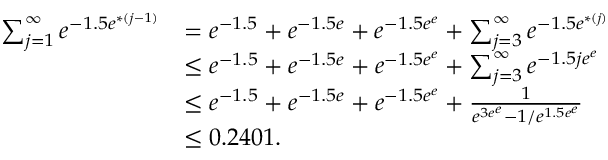Convert formula to latex. <formula><loc_0><loc_0><loc_500><loc_500>\begin{array} { r l } { \sum _ { j = 1 } ^ { \infty } e ^ { - 1 . 5 { e ^ { * ( j - 1 ) } } } } & { = { e ^ { - 1 . 5 } } + { e ^ { - 1 . 5 e } } + { e ^ { - 1 . 5 e ^ { e } } } + \sum _ { j = 3 } ^ { \infty } e ^ { - 1 . 5 { e ^ { * ( j ) } } } } \\ & { \leq { e ^ { - 1 . 5 } } + { e ^ { - 1 . 5 e } } + { e ^ { - 1 . 5 e ^ { e } } } + \sum _ { j = 3 } ^ { \infty } e ^ { - 1 . 5 { j e ^ { e } } } } \\ & { \leq { e ^ { - 1 . 5 } } + { e ^ { - 1 . 5 e } } + { e ^ { - 1 . 5 e ^ { e } } } + \frac { 1 } e ^ { 3 e ^ { e } } - 1 / e ^ { 1 . 5 e ^ { e } } } } \\ & { \leq 0 . 2 4 0 1 . } \end{array}</formula> 